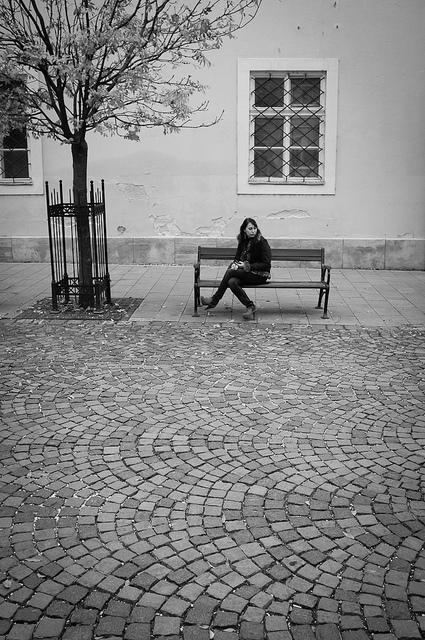What is the woman sitting on?
Quick response, please. Bench. Is this in color?
Answer briefly. No. Is the street paved?
Write a very short answer. Yes. 